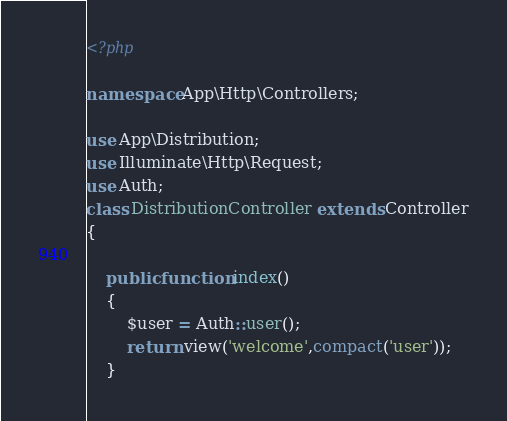Convert code to text. <code><loc_0><loc_0><loc_500><loc_500><_PHP_><?php

namespace App\Http\Controllers;

use App\Distribution;
use Illuminate\Http\Request;
use Auth;
class DistributionController extends Controller
{

    public function index()
    {
        $user = Auth::user();
        return view('welcome',compact('user'));
    }
</code> 